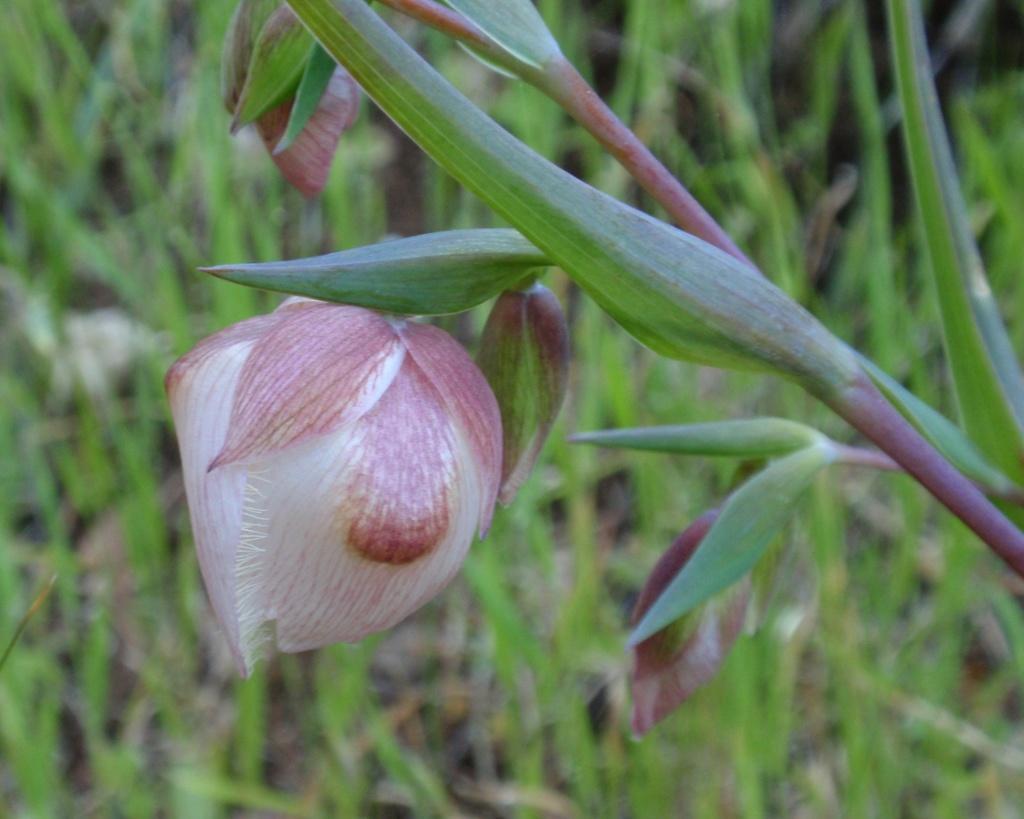Describe this image in one or two sentences. This image consists of a plant. There is a flower in the middle. It is in white color. 